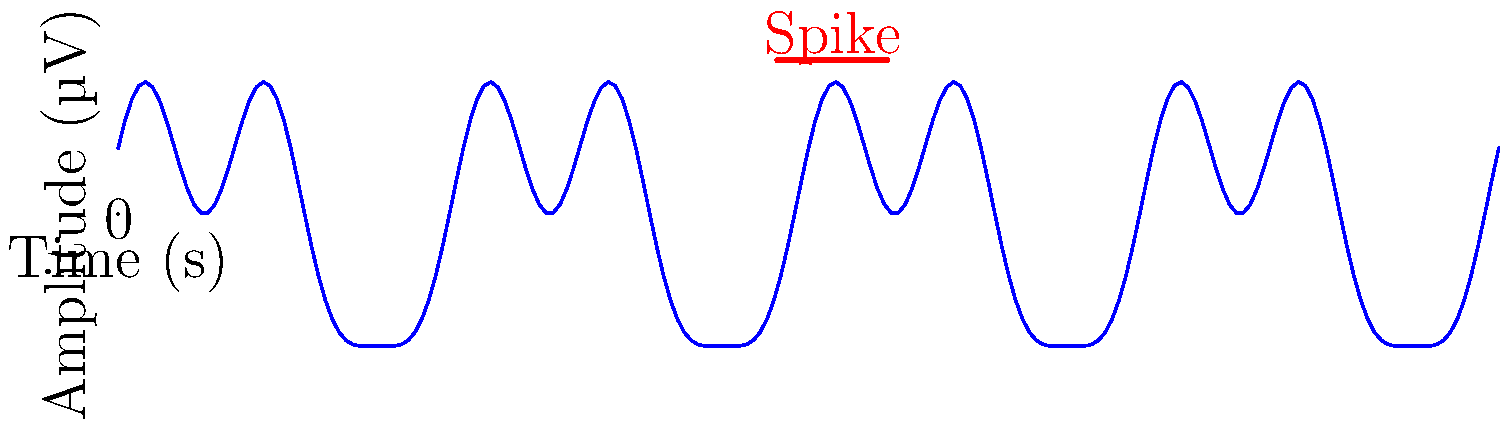Analyze the EEG waveform pattern shown above. Which type of epileptic seizure is most likely associated with this pattern, characterized by the presence of sharp spikes? To determine the type of epileptic seizure associated with this EEG waveform pattern, let's analyze it step-by-step:

1. Observe the overall pattern: The waveform shows a complex, oscillatory pattern with varying frequencies and amplitudes.

2. Identify key features: There is a prominent sharp spike indicated in red on the graph.

3. Interpret the spike: Sharp spikes in EEG are often associated with epileptiform activity.

4. Consider the frequency and distribution: The spike appears to be isolated and not part of a rhythmic pattern.

5. Compare with known epilepsy patterns:
   a) Absence seizures typically show 3 Hz spike-and-wave discharges.
   b) Tonic-clonic seizures often display a progression of patterns.
   c) Focal seizures can show isolated spikes or sharp waves in a specific brain region.

6. Conclusion: The presence of an isolated sharp spike is most consistent with focal epilepsy, particularly focal aware (simple partial) seizures.

Focal aware seizures originate in a specific area of the brain and often manifest as brief, localized electrical discharges, which can appear as sharp spikes on an EEG. This pattern is distinct from the more generalized or rhythmic patterns seen in other types of epilepsy.
Answer: Focal aware (simple partial) seizure 